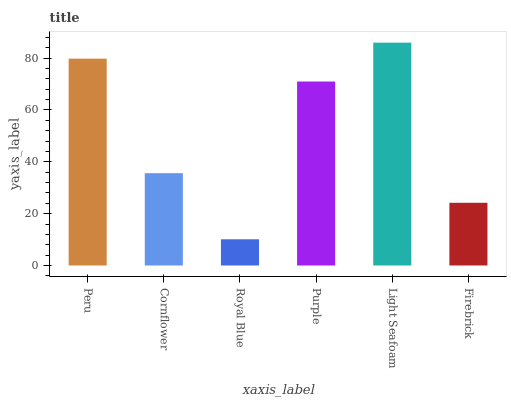Is Cornflower the minimum?
Answer yes or no. No. Is Cornflower the maximum?
Answer yes or no. No. Is Peru greater than Cornflower?
Answer yes or no. Yes. Is Cornflower less than Peru?
Answer yes or no. Yes. Is Cornflower greater than Peru?
Answer yes or no. No. Is Peru less than Cornflower?
Answer yes or no. No. Is Purple the high median?
Answer yes or no. Yes. Is Cornflower the low median?
Answer yes or no. Yes. Is Royal Blue the high median?
Answer yes or no. No. Is Light Seafoam the low median?
Answer yes or no. No. 